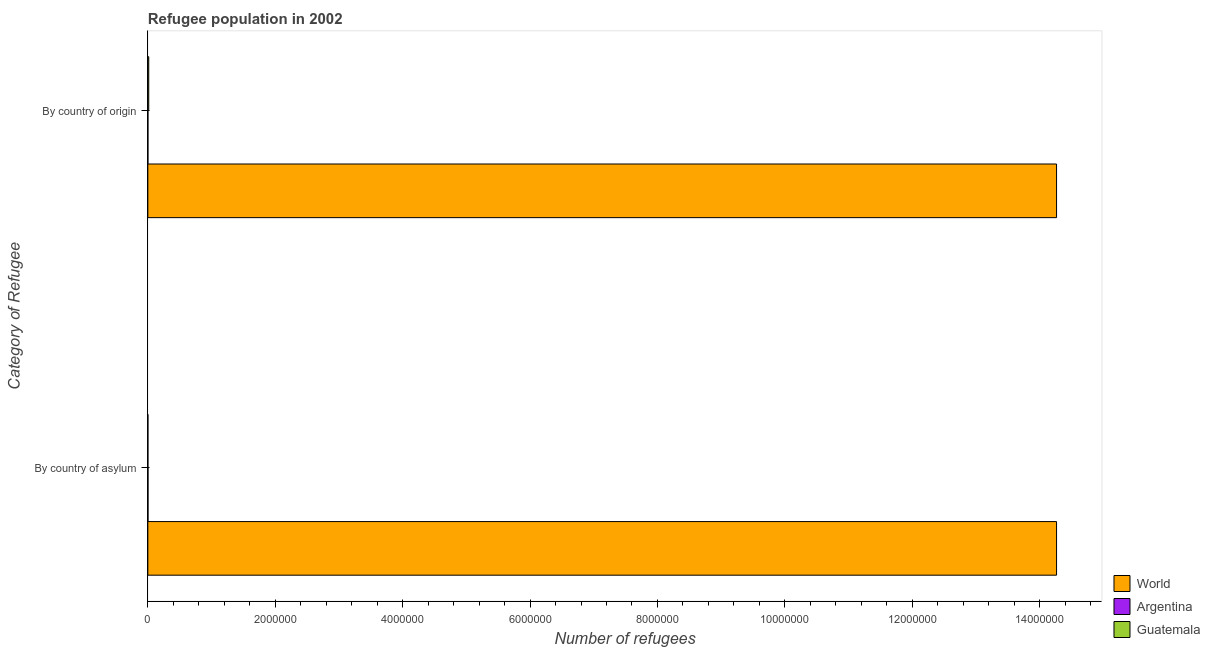How many different coloured bars are there?
Your answer should be very brief. 3. How many bars are there on the 2nd tick from the bottom?
Make the answer very short. 3. What is the label of the 2nd group of bars from the top?
Your answer should be compact. By country of asylum. What is the number of refugees by country of asylum in World?
Keep it short and to the point. 1.43e+07. Across all countries, what is the maximum number of refugees by country of origin?
Give a very brief answer. 1.43e+07. Across all countries, what is the minimum number of refugees by country of asylum?
Your answer should be very brief. 733. In which country was the number of refugees by country of asylum maximum?
Offer a very short reply. World. In which country was the number of refugees by country of asylum minimum?
Your response must be concise. Guatemala. What is the total number of refugees by country of origin in the graph?
Provide a succinct answer. 1.43e+07. What is the difference between the number of refugees by country of asylum in Argentina and that in World?
Provide a succinct answer. -1.43e+07. What is the difference between the number of refugees by country of origin in Argentina and the number of refugees by country of asylum in Guatemala?
Your response must be concise. 38. What is the average number of refugees by country of asylum per country?
Ensure brevity in your answer.  4.76e+06. What is the difference between the number of refugees by country of asylum and number of refugees by country of origin in Guatemala?
Your answer should be compact. -1.32e+04. What is the ratio of the number of refugees by country of origin in Argentina to that in World?
Ensure brevity in your answer.  5.404705542739339e-5. In how many countries, is the number of refugees by country of asylum greater than the average number of refugees by country of asylum taken over all countries?
Make the answer very short. 1. What does the 3rd bar from the bottom in By country of origin represents?
Provide a short and direct response. Guatemala. How many countries are there in the graph?
Offer a terse response. 3. Are the values on the major ticks of X-axis written in scientific E-notation?
Provide a succinct answer. No. Does the graph contain any zero values?
Ensure brevity in your answer.  No. Does the graph contain grids?
Provide a succinct answer. No. How are the legend labels stacked?
Ensure brevity in your answer.  Vertical. What is the title of the graph?
Offer a terse response. Refugee population in 2002. What is the label or title of the X-axis?
Offer a terse response. Number of refugees. What is the label or title of the Y-axis?
Your answer should be compact. Category of Refugee. What is the Number of refugees of World in By country of asylum?
Make the answer very short. 1.43e+07. What is the Number of refugees of Argentina in By country of asylum?
Provide a short and direct response. 2439. What is the Number of refugees of Guatemala in By country of asylum?
Provide a succinct answer. 733. What is the Number of refugees in World in By country of origin?
Give a very brief answer. 1.43e+07. What is the Number of refugees of Argentina in By country of origin?
Offer a terse response. 771. What is the Number of refugees in Guatemala in By country of origin?
Your answer should be very brief. 1.39e+04. Across all Category of Refugee, what is the maximum Number of refugees in World?
Provide a short and direct response. 1.43e+07. Across all Category of Refugee, what is the maximum Number of refugees in Argentina?
Your answer should be compact. 2439. Across all Category of Refugee, what is the maximum Number of refugees of Guatemala?
Make the answer very short. 1.39e+04. Across all Category of Refugee, what is the minimum Number of refugees in World?
Your answer should be compact. 1.43e+07. Across all Category of Refugee, what is the minimum Number of refugees in Argentina?
Your response must be concise. 771. Across all Category of Refugee, what is the minimum Number of refugees of Guatemala?
Give a very brief answer. 733. What is the total Number of refugees of World in the graph?
Your response must be concise. 2.85e+07. What is the total Number of refugees of Argentina in the graph?
Keep it short and to the point. 3210. What is the total Number of refugees of Guatemala in the graph?
Make the answer very short. 1.46e+04. What is the difference between the Number of refugees of Argentina in By country of asylum and that in By country of origin?
Provide a succinct answer. 1668. What is the difference between the Number of refugees of Guatemala in By country of asylum and that in By country of origin?
Your answer should be compact. -1.32e+04. What is the difference between the Number of refugees of World in By country of asylum and the Number of refugees of Argentina in By country of origin?
Ensure brevity in your answer.  1.43e+07. What is the difference between the Number of refugees in World in By country of asylum and the Number of refugees in Guatemala in By country of origin?
Your response must be concise. 1.43e+07. What is the difference between the Number of refugees of Argentina in By country of asylum and the Number of refugees of Guatemala in By country of origin?
Offer a very short reply. -1.14e+04. What is the average Number of refugees in World per Category of Refugee?
Provide a short and direct response. 1.43e+07. What is the average Number of refugees of Argentina per Category of Refugee?
Give a very brief answer. 1605. What is the average Number of refugees of Guatemala per Category of Refugee?
Your answer should be very brief. 7310.5. What is the difference between the Number of refugees in World and Number of refugees in Argentina in By country of asylum?
Give a very brief answer. 1.43e+07. What is the difference between the Number of refugees of World and Number of refugees of Guatemala in By country of asylum?
Your answer should be very brief. 1.43e+07. What is the difference between the Number of refugees of Argentina and Number of refugees of Guatemala in By country of asylum?
Ensure brevity in your answer.  1706. What is the difference between the Number of refugees of World and Number of refugees of Argentina in By country of origin?
Make the answer very short. 1.43e+07. What is the difference between the Number of refugees in World and Number of refugees in Guatemala in By country of origin?
Your response must be concise. 1.43e+07. What is the difference between the Number of refugees in Argentina and Number of refugees in Guatemala in By country of origin?
Provide a succinct answer. -1.31e+04. What is the ratio of the Number of refugees of World in By country of asylum to that in By country of origin?
Provide a succinct answer. 1. What is the ratio of the Number of refugees in Argentina in By country of asylum to that in By country of origin?
Provide a succinct answer. 3.16. What is the ratio of the Number of refugees of Guatemala in By country of asylum to that in By country of origin?
Make the answer very short. 0.05. What is the difference between the highest and the second highest Number of refugees of World?
Keep it short and to the point. 0. What is the difference between the highest and the second highest Number of refugees of Argentina?
Provide a short and direct response. 1668. What is the difference between the highest and the second highest Number of refugees in Guatemala?
Ensure brevity in your answer.  1.32e+04. What is the difference between the highest and the lowest Number of refugees of Argentina?
Provide a short and direct response. 1668. What is the difference between the highest and the lowest Number of refugees in Guatemala?
Offer a very short reply. 1.32e+04. 